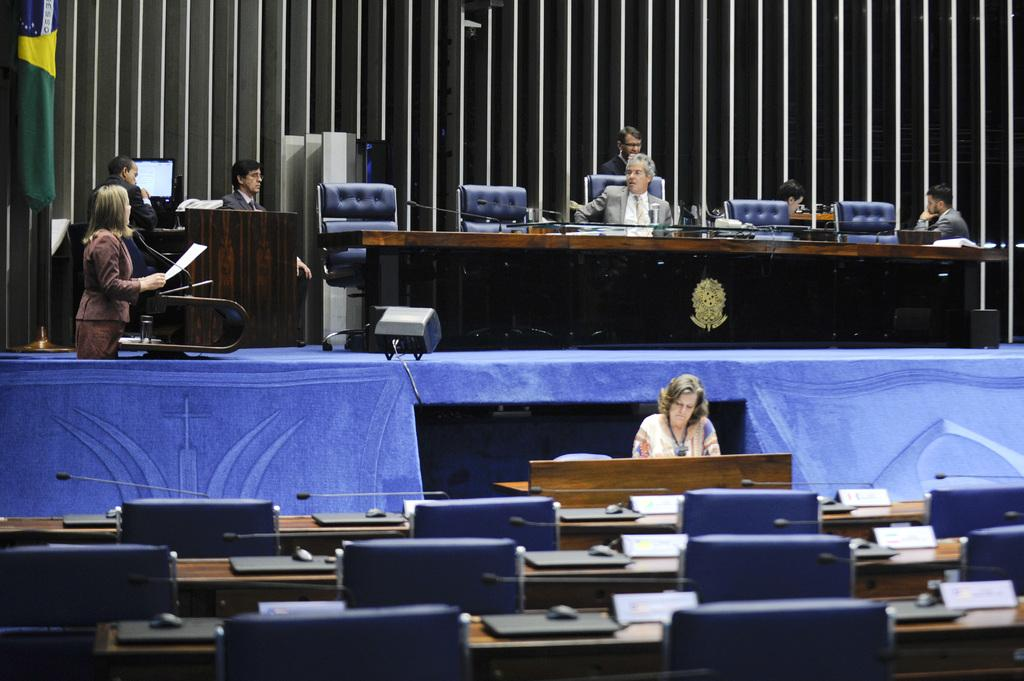What is the woman doing on the left side of the image? The woman is standing on the left side of the image and speaking into a microphone. What is the position of the man in the image? The man is sitting in a chair in the middle of the image. What type of tramp can be seen jumping over the bridge in the image? There is no tramp or bridge present in the image. 